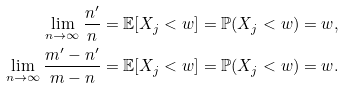<formula> <loc_0><loc_0><loc_500><loc_500>\lim _ { n \to \infty } \frac { n ^ { \prime } } { n } & = \mathbb { E } [ X _ { j } < w ] = \mathbb { P } ( X _ { j } < w ) = w , \\ \lim _ { n \to \infty } \frac { m ^ { \prime } - n ^ { \prime } } { m - n } & = \mathbb { E } [ X _ { j } < w ] = \mathbb { P } ( X _ { j } < w ) = w .</formula> 